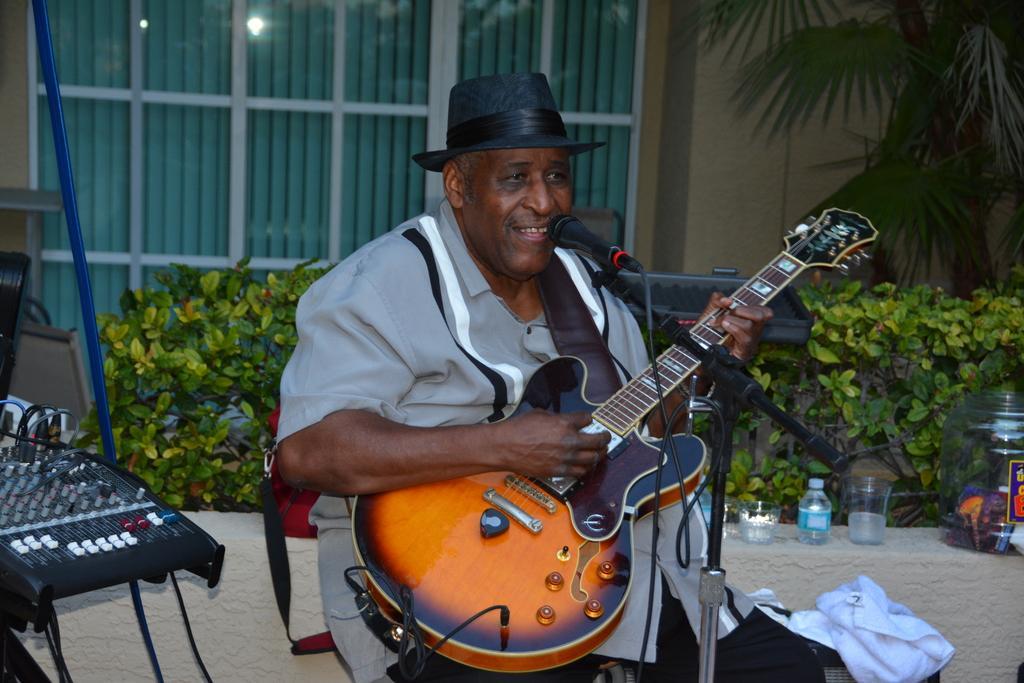Please provide a concise description of this image. On the background we can see a wall, tree, window with curtains. these are plants. Here we can see one man sitting in front of a mike and playing a guitar and singing. He wore black colour hat. This is a electronic device. we can see a bottle, glass and a container here. 